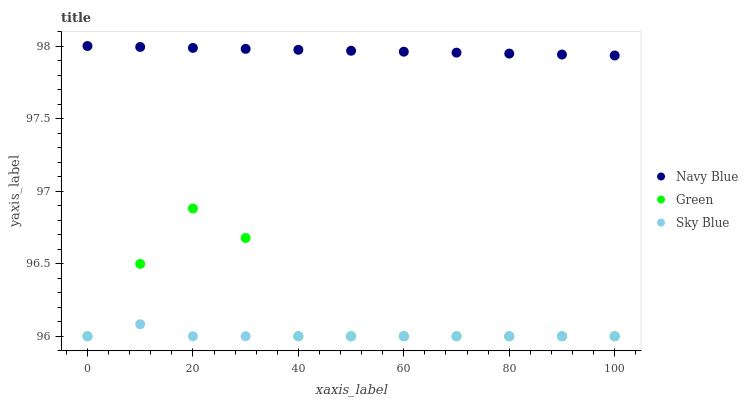Does Sky Blue have the minimum area under the curve?
Answer yes or no. Yes. Does Navy Blue have the maximum area under the curve?
Answer yes or no. Yes. Does Green have the minimum area under the curve?
Answer yes or no. No. Does Green have the maximum area under the curve?
Answer yes or no. No. Is Navy Blue the smoothest?
Answer yes or no. Yes. Is Green the roughest?
Answer yes or no. Yes. Is Sky Blue the smoothest?
Answer yes or no. No. Is Sky Blue the roughest?
Answer yes or no. No. Does Green have the lowest value?
Answer yes or no. Yes. Does Navy Blue have the highest value?
Answer yes or no. Yes. Does Green have the highest value?
Answer yes or no. No. Is Sky Blue less than Navy Blue?
Answer yes or no. Yes. Is Navy Blue greater than Sky Blue?
Answer yes or no. Yes. Does Sky Blue intersect Green?
Answer yes or no. Yes. Is Sky Blue less than Green?
Answer yes or no. No. Is Sky Blue greater than Green?
Answer yes or no. No. Does Sky Blue intersect Navy Blue?
Answer yes or no. No. 